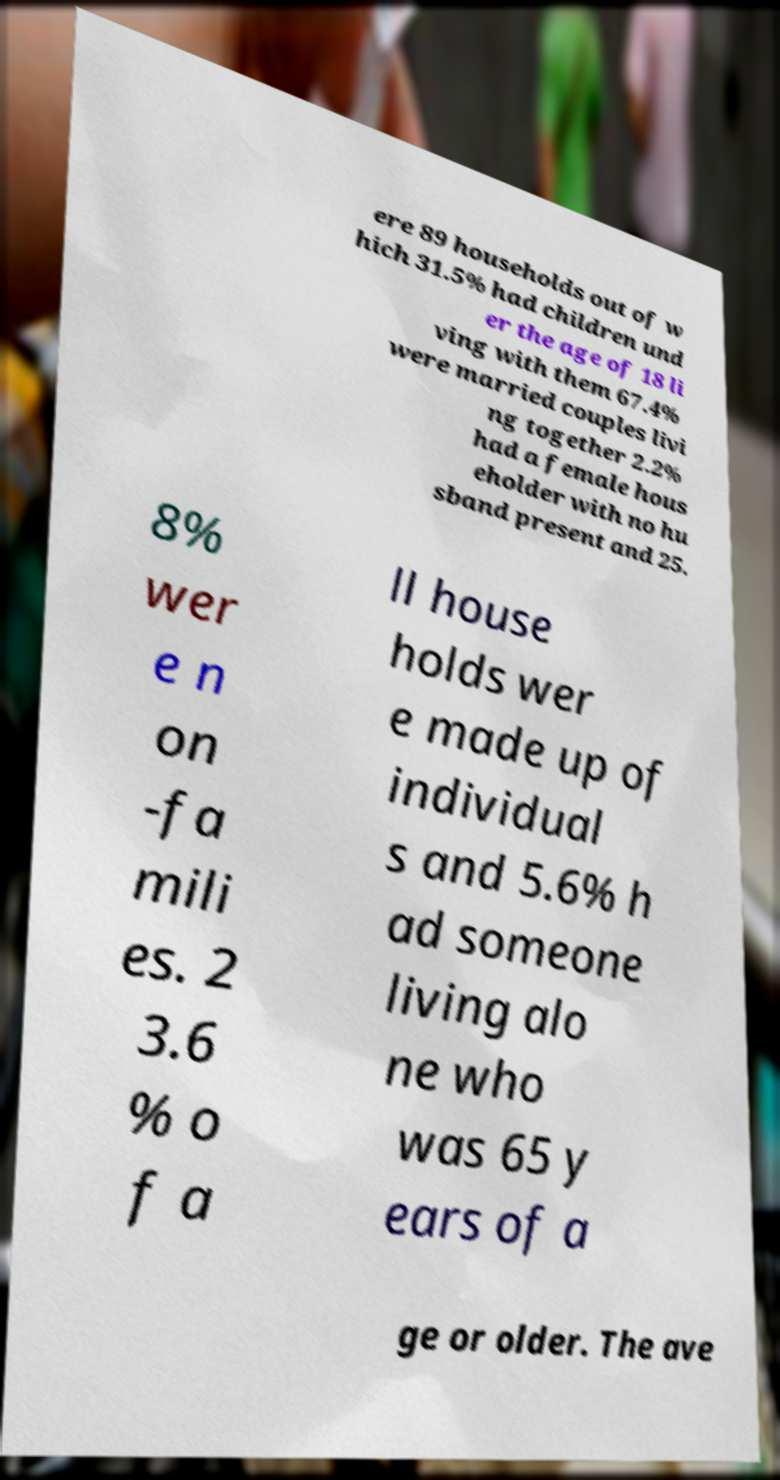What messages or text are displayed in this image? I need them in a readable, typed format. ere 89 households out of w hich 31.5% had children und er the age of 18 li ving with them 67.4% were married couples livi ng together 2.2% had a female hous eholder with no hu sband present and 25. 8% wer e n on -fa mili es. 2 3.6 % o f a ll house holds wer e made up of individual s and 5.6% h ad someone living alo ne who was 65 y ears of a ge or older. The ave 